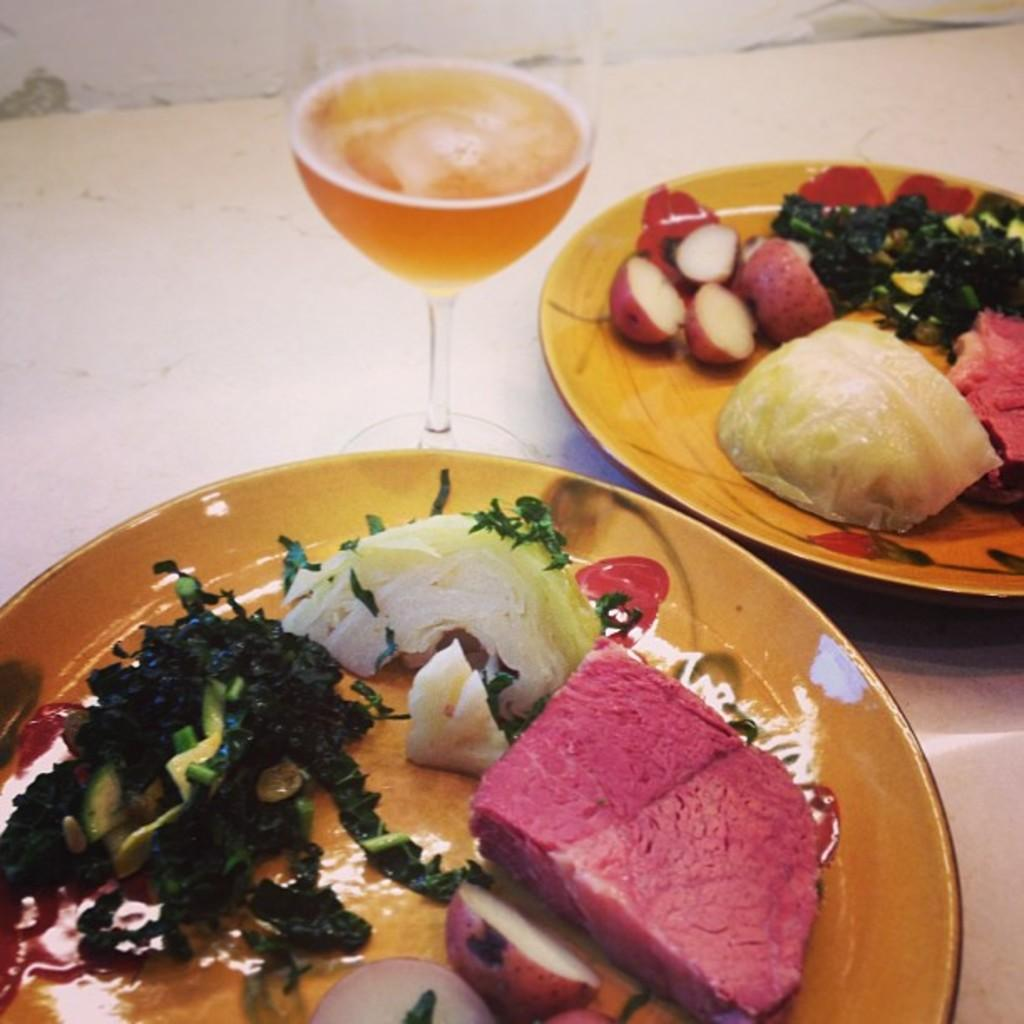What is on the plates that are visible in the image? There is food on plates in the image. What type of drink is in the glass on the table in the image? There is a glass of wine on the table in the image. What piece of furniture is present in the image? The table is present in the image. What color is the scarf draped over the neck of the person in the image? There is no person or scarf present in the image. Can you tell me how many baseballs are on the table in the image? There are no baseballs present in the image. 